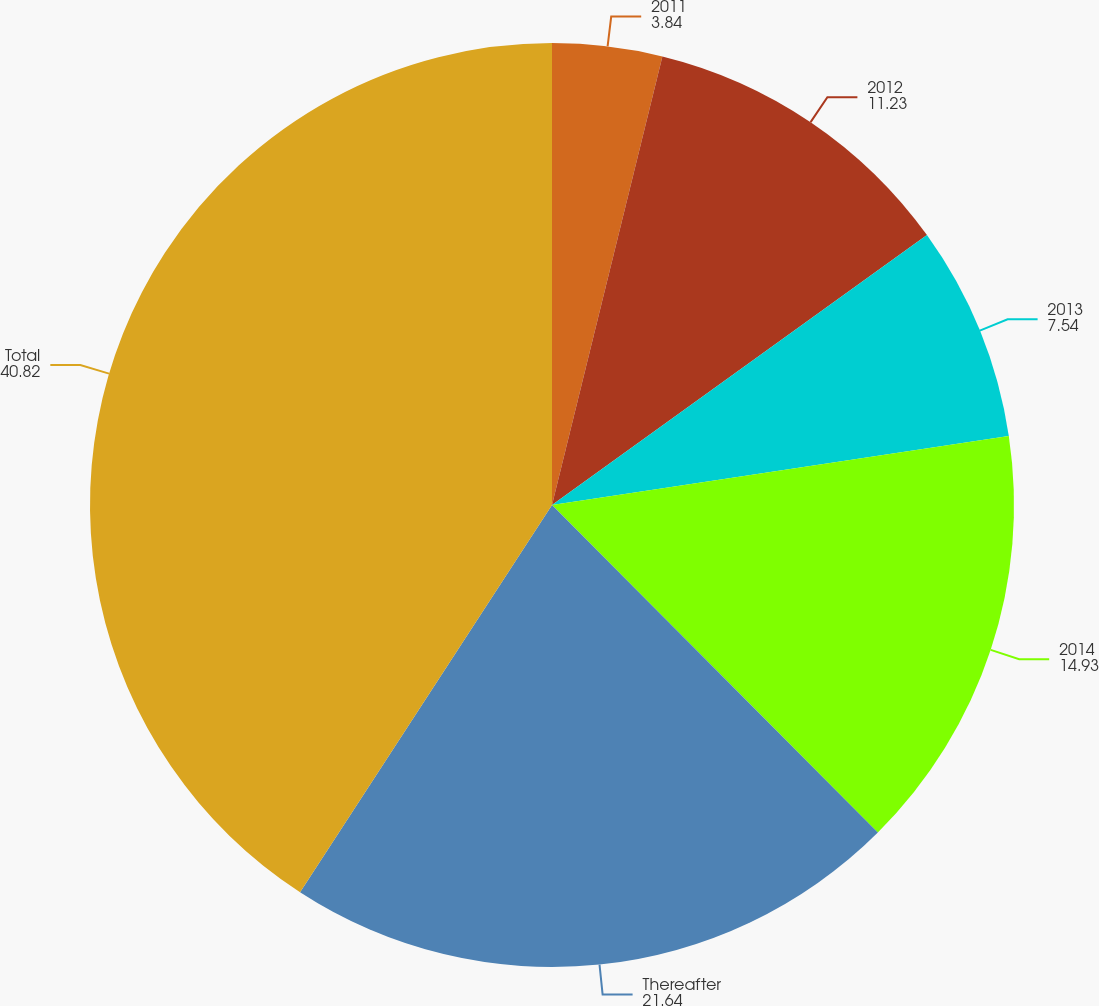<chart> <loc_0><loc_0><loc_500><loc_500><pie_chart><fcel>2011<fcel>2012<fcel>2013<fcel>2014<fcel>Thereafter<fcel>Total<nl><fcel>3.84%<fcel>11.23%<fcel>7.54%<fcel>14.93%<fcel>21.64%<fcel>40.82%<nl></chart> 